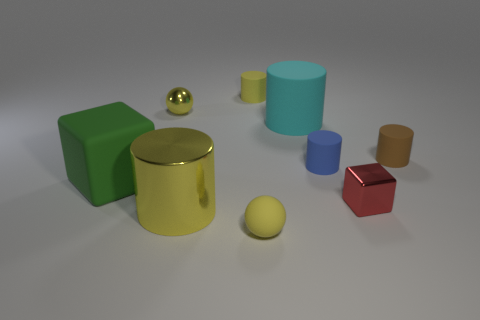How many objects are yellow spheres or things behind the brown rubber thing?
Ensure brevity in your answer.  4. What number of big metallic cylinders are there?
Make the answer very short. 1. Are there any green metal objects that have the same size as the blue matte cylinder?
Ensure brevity in your answer.  No. Is the number of tiny blue matte things behind the cyan object less than the number of large purple metal objects?
Keep it short and to the point. No. Do the brown rubber cylinder and the yellow shiny ball have the same size?
Provide a short and direct response. Yes. There is a yellow cylinder that is made of the same material as the small cube; what size is it?
Keep it short and to the point. Large. How many cylinders are the same color as the tiny rubber ball?
Ensure brevity in your answer.  2. Are there fewer yellow balls in front of the big green block than blocks left of the blue matte thing?
Offer a very short reply. No. There is a big object that is in front of the green cube; is it the same shape as the cyan rubber thing?
Make the answer very short. Yes. Do the yellow sphere in front of the matte block and the big cyan object have the same material?
Give a very brief answer. Yes. 